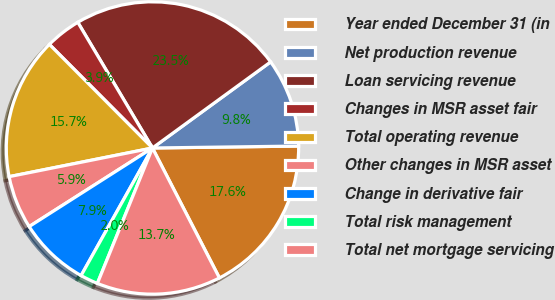Convert chart. <chart><loc_0><loc_0><loc_500><loc_500><pie_chart><fcel>Year ended December 31 (in<fcel>Net production revenue<fcel>Loan servicing revenue<fcel>Changes in MSR asset fair<fcel>Total operating revenue<fcel>Other changes in MSR asset<fcel>Change in derivative fair<fcel>Total risk management<fcel>Total net mortgage servicing<nl><fcel>17.64%<fcel>9.81%<fcel>23.51%<fcel>3.93%<fcel>15.68%<fcel>5.89%<fcel>7.85%<fcel>1.97%<fcel>13.72%<nl></chart> 